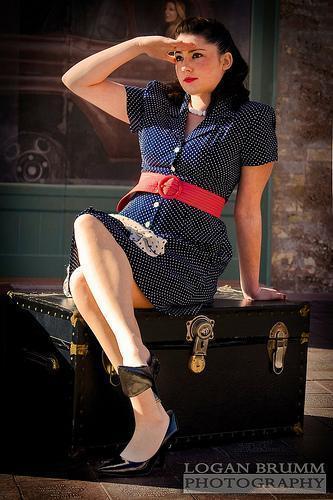How many trunks are visible?
Give a very brief answer. 1. 